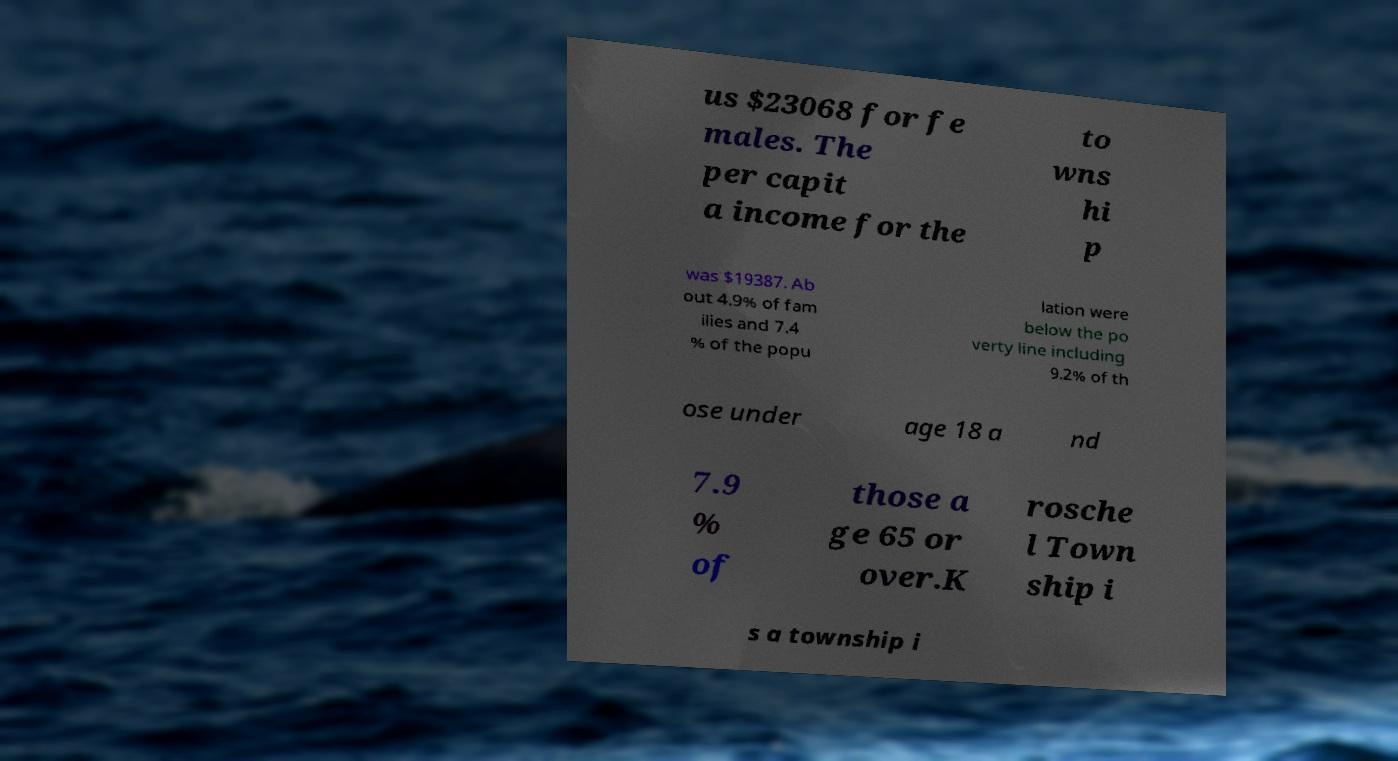Could you extract and type out the text from this image? us $23068 for fe males. The per capit a income for the to wns hi p was $19387. Ab out 4.9% of fam ilies and 7.4 % of the popu lation were below the po verty line including 9.2% of th ose under age 18 a nd 7.9 % of those a ge 65 or over.K rosche l Town ship i s a township i 